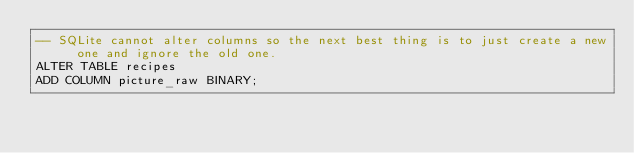Convert code to text. <code><loc_0><loc_0><loc_500><loc_500><_SQL_>-- SQLite cannot alter columns so the next best thing is to just create a new one and ignore the old one.
ALTER TABLE recipes
ADD COLUMN picture_raw BINARY;</code> 